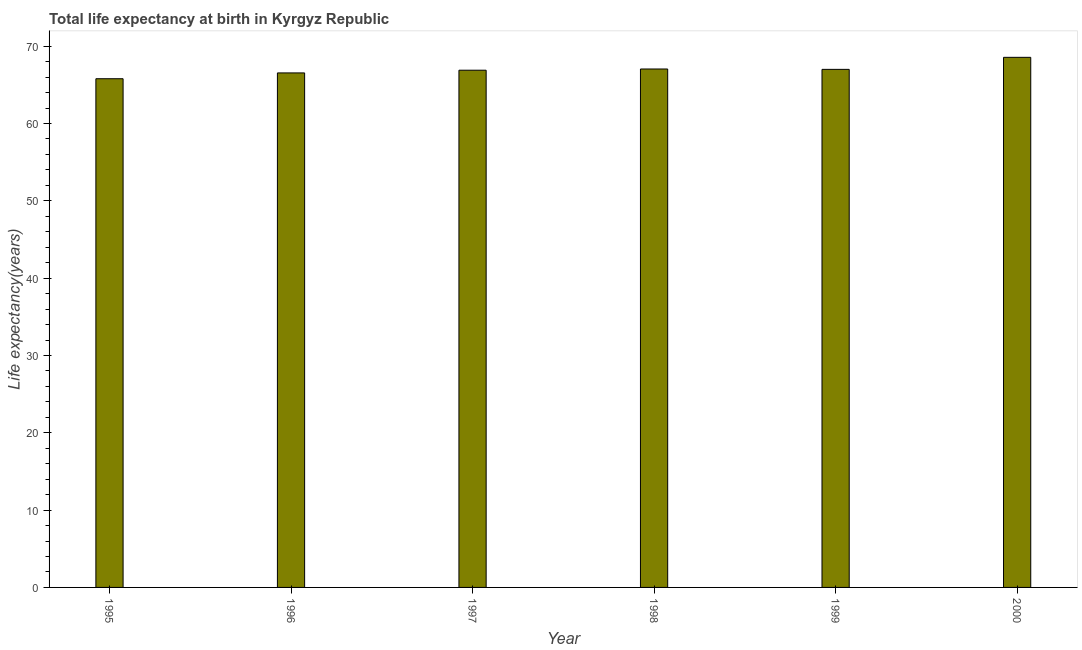Does the graph contain any zero values?
Provide a short and direct response. No. What is the title of the graph?
Provide a succinct answer. Total life expectancy at birth in Kyrgyz Republic. What is the label or title of the X-axis?
Offer a terse response. Year. What is the label or title of the Y-axis?
Ensure brevity in your answer.  Life expectancy(years). What is the life expectancy at birth in 1996?
Ensure brevity in your answer.  66.54. Across all years, what is the maximum life expectancy at birth?
Give a very brief answer. 68.56. Across all years, what is the minimum life expectancy at birth?
Provide a short and direct response. 65.79. What is the sum of the life expectancy at birth?
Your answer should be compact. 401.84. What is the difference between the life expectancy at birth in 1997 and 1998?
Ensure brevity in your answer.  -0.16. What is the average life expectancy at birth per year?
Ensure brevity in your answer.  66.97. What is the median life expectancy at birth?
Provide a succinct answer. 66.95. Do a majority of the years between 1999 and 2000 (inclusive) have life expectancy at birth greater than 6 years?
Offer a terse response. Yes. What is the ratio of the life expectancy at birth in 1995 to that in 1998?
Offer a very short reply. 0.98. Is the difference between the life expectancy at birth in 1995 and 1998 greater than the difference between any two years?
Offer a terse response. No. What is the difference between the highest and the second highest life expectancy at birth?
Offer a terse response. 1.51. Is the sum of the life expectancy at birth in 1998 and 1999 greater than the maximum life expectancy at birth across all years?
Your answer should be compact. Yes. What is the difference between the highest and the lowest life expectancy at birth?
Ensure brevity in your answer.  2.77. In how many years, is the life expectancy at birth greater than the average life expectancy at birth taken over all years?
Provide a succinct answer. 3. How many years are there in the graph?
Provide a succinct answer. 6. What is the difference between two consecutive major ticks on the Y-axis?
Ensure brevity in your answer.  10. Are the values on the major ticks of Y-axis written in scientific E-notation?
Your answer should be very brief. No. What is the Life expectancy(years) in 1995?
Provide a short and direct response. 65.79. What is the Life expectancy(years) of 1996?
Offer a terse response. 66.54. What is the Life expectancy(years) of 1997?
Your response must be concise. 66.89. What is the Life expectancy(years) in 1998?
Offer a terse response. 67.05. What is the Life expectancy(years) in 1999?
Keep it short and to the point. 67. What is the Life expectancy(years) in 2000?
Ensure brevity in your answer.  68.56. What is the difference between the Life expectancy(years) in 1995 and 1996?
Ensure brevity in your answer.  -0.75. What is the difference between the Life expectancy(years) in 1995 and 1997?
Provide a succinct answer. -1.1. What is the difference between the Life expectancy(years) in 1995 and 1998?
Provide a short and direct response. -1.26. What is the difference between the Life expectancy(years) in 1995 and 1999?
Offer a very short reply. -1.21. What is the difference between the Life expectancy(years) in 1995 and 2000?
Your answer should be very brief. -2.77. What is the difference between the Life expectancy(years) in 1996 and 1997?
Offer a terse response. -0.35. What is the difference between the Life expectancy(years) in 1996 and 1998?
Provide a succinct answer. -0.51. What is the difference between the Life expectancy(years) in 1996 and 1999?
Make the answer very short. -0.46. What is the difference between the Life expectancy(years) in 1996 and 2000?
Give a very brief answer. -2.01. What is the difference between the Life expectancy(years) in 1997 and 1998?
Ensure brevity in your answer.  -0.16. What is the difference between the Life expectancy(years) in 1997 and 1999?
Keep it short and to the point. -0.11. What is the difference between the Life expectancy(years) in 1997 and 2000?
Your answer should be very brief. -1.67. What is the difference between the Life expectancy(years) in 1998 and 1999?
Your response must be concise. 0.05. What is the difference between the Life expectancy(years) in 1998 and 2000?
Offer a very short reply. -1.51. What is the difference between the Life expectancy(years) in 1999 and 2000?
Provide a succinct answer. -1.56. What is the ratio of the Life expectancy(years) in 1995 to that in 1996?
Keep it short and to the point. 0.99. What is the ratio of the Life expectancy(years) in 1995 to that in 1997?
Your answer should be very brief. 0.98. What is the ratio of the Life expectancy(years) in 1995 to that in 1998?
Offer a very short reply. 0.98. What is the ratio of the Life expectancy(years) in 1995 to that in 1999?
Provide a succinct answer. 0.98. What is the ratio of the Life expectancy(years) in 1995 to that in 2000?
Offer a very short reply. 0.96. What is the ratio of the Life expectancy(years) in 1996 to that in 1998?
Provide a short and direct response. 0.99. What is the ratio of the Life expectancy(years) in 1996 to that in 1999?
Give a very brief answer. 0.99. What is the ratio of the Life expectancy(years) in 1996 to that in 2000?
Your answer should be compact. 0.97. What is the ratio of the Life expectancy(years) in 1997 to that in 1999?
Offer a very short reply. 1. What is the ratio of the Life expectancy(years) in 1999 to that in 2000?
Your answer should be compact. 0.98. 